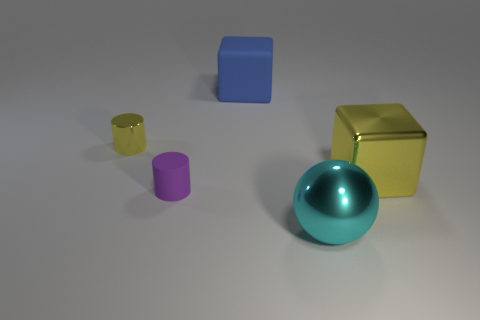Add 1 large gray metallic balls. How many objects exist? 6 Subtract all cylinders. How many objects are left? 3 Add 1 rubber objects. How many rubber objects are left? 3 Add 2 yellow metal cylinders. How many yellow metal cylinders exist? 3 Subtract 0 purple cubes. How many objects are left? 5 Subtract all tiny objects. Subtract all cyan metallic objects. How many objects are left? 2 